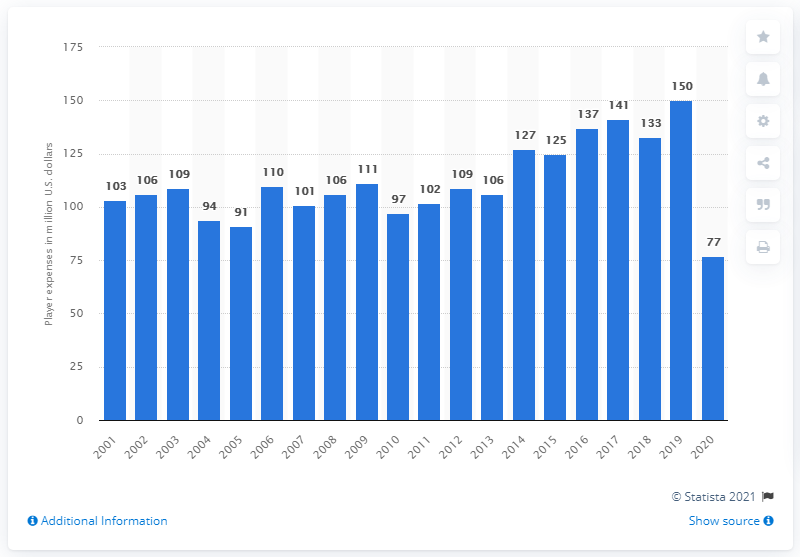Indicate a few pertinent items in this graphic. The team's payroll in dollars for 2020 was approximately 77.... 